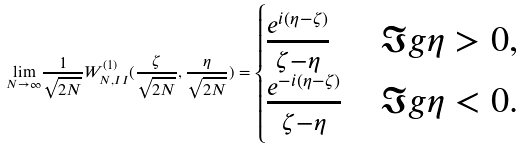<formula> <loc_0><loc_0><loc_500><loc_500>\underset { N \rightarrow \infty } { \lim } \frac { 1 } { \sqrt { 2 N } } W _ { N , I I } ^ { ( 1 ) } ( \frac { \zeta } { \sqrt { 2 N } } , \frac { \eta } { \sqrt { 2 N } } ) = \begin{cases} \frac { e ^ { i ( \eta - \zeta ) } } { \zeta - \eta } & \Im g \eta > 0 , \\ \frac { e ^ { - i ( \eta - \zeta ) } } { \zeta - \eta } & \Im g \eta < 0 . \end{cases}</formula> 